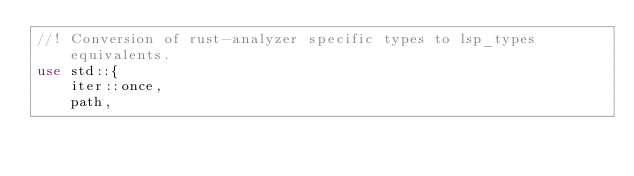<code> <loc_0><loc_0><loc_500><loc_500><_Rust_>//! Conversion of rust-analyzer specific types to lsp_types equivalents.
use std::{
    iter::once,
    path,</code> 